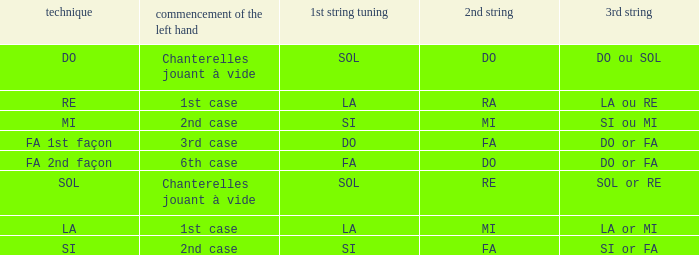For the 2nd string of Do and an Accord du 1st string of FA what is the Depart de la main gauche? 6th case. 